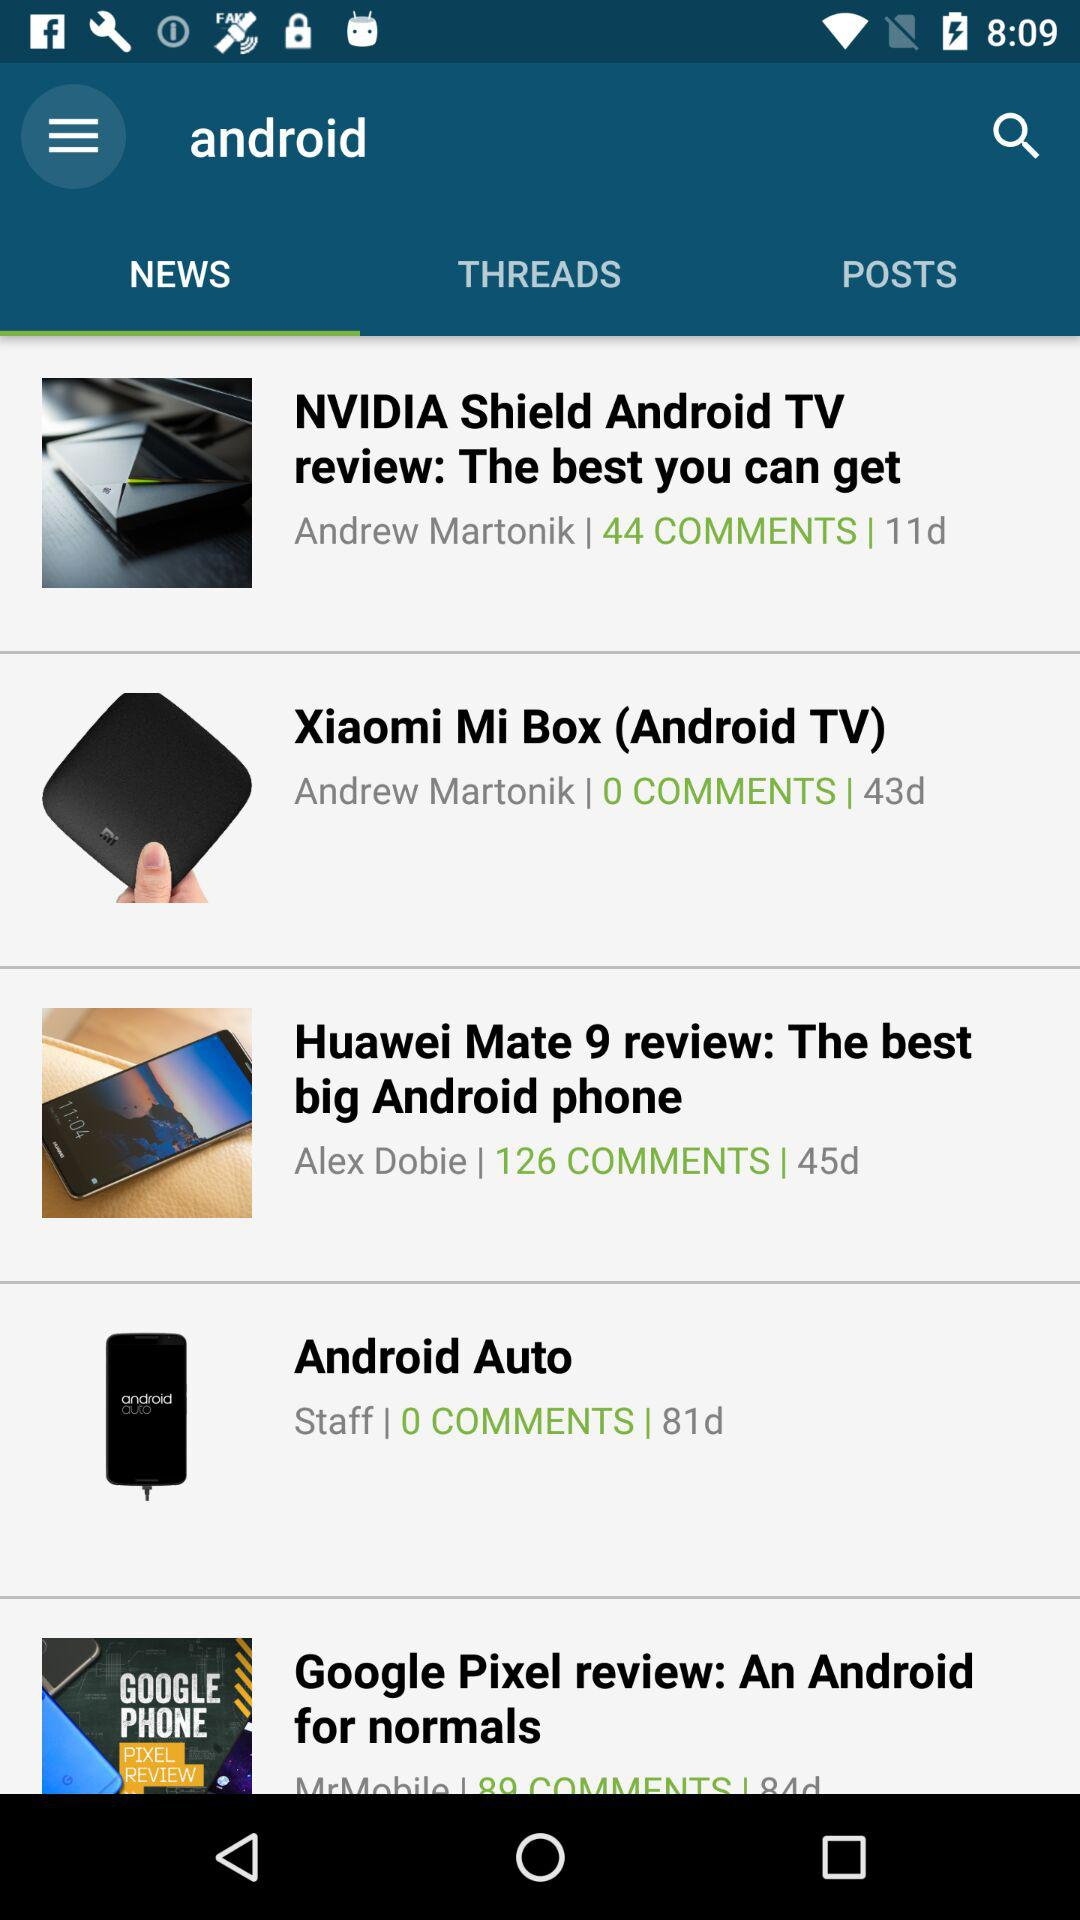How many days ago was "NVIDIA Shield Android TV review: The best you can get" posted? It was posted 11 days ago. 